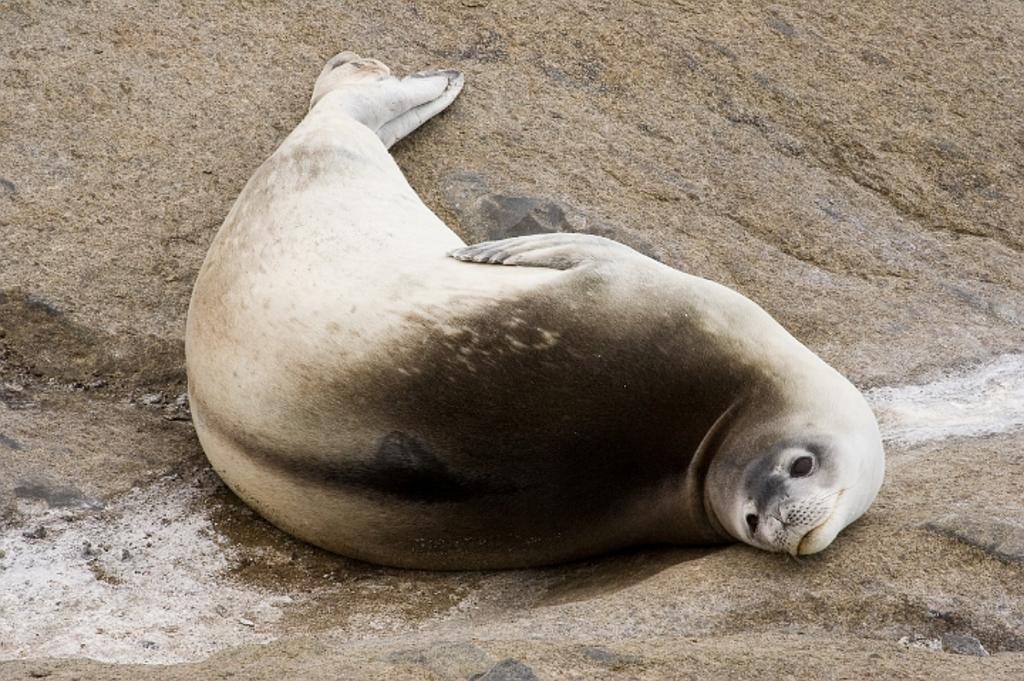Could you give a brief overview of what you see in this image? In this picture I can see a sea lion on the sand and water. 